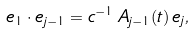Convert formula to latex. <formula><loc_0><loc_0><loc_500><loc_500>e _ { 1 } \cdot e _ { j - 1 } = c ^ { - 1 } \, A _ { j - 1 } ( t ) \, e _ { j } ,</formula> 